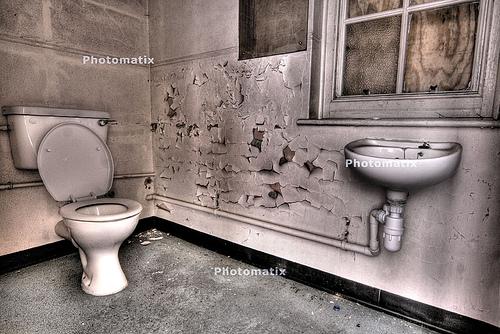Is the window open?
Be succinct. No. How many toilets are here?
Answer briefly. 1. Is the bathroom dirty or clean?
Short answer required. Dirty. Which side of the tank is the handle on?
Give a very brief answer. Right. 